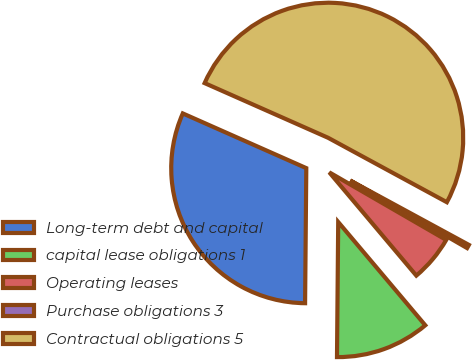Convert chart. <chart><loc_0><loc_0><loc_500><loc_500><pie_chart><fcel>Long-term debt and capital<fcel>capital lease obligations 1<fcel>Operating leases<fcel>Purchase obligations 3<fcel>Contractual obligations 5<nl><fcel>31.49%<fcel>11.29%<fcel>5.51%<fcel>0.43%<fcel>51.27%<nl></chart> 